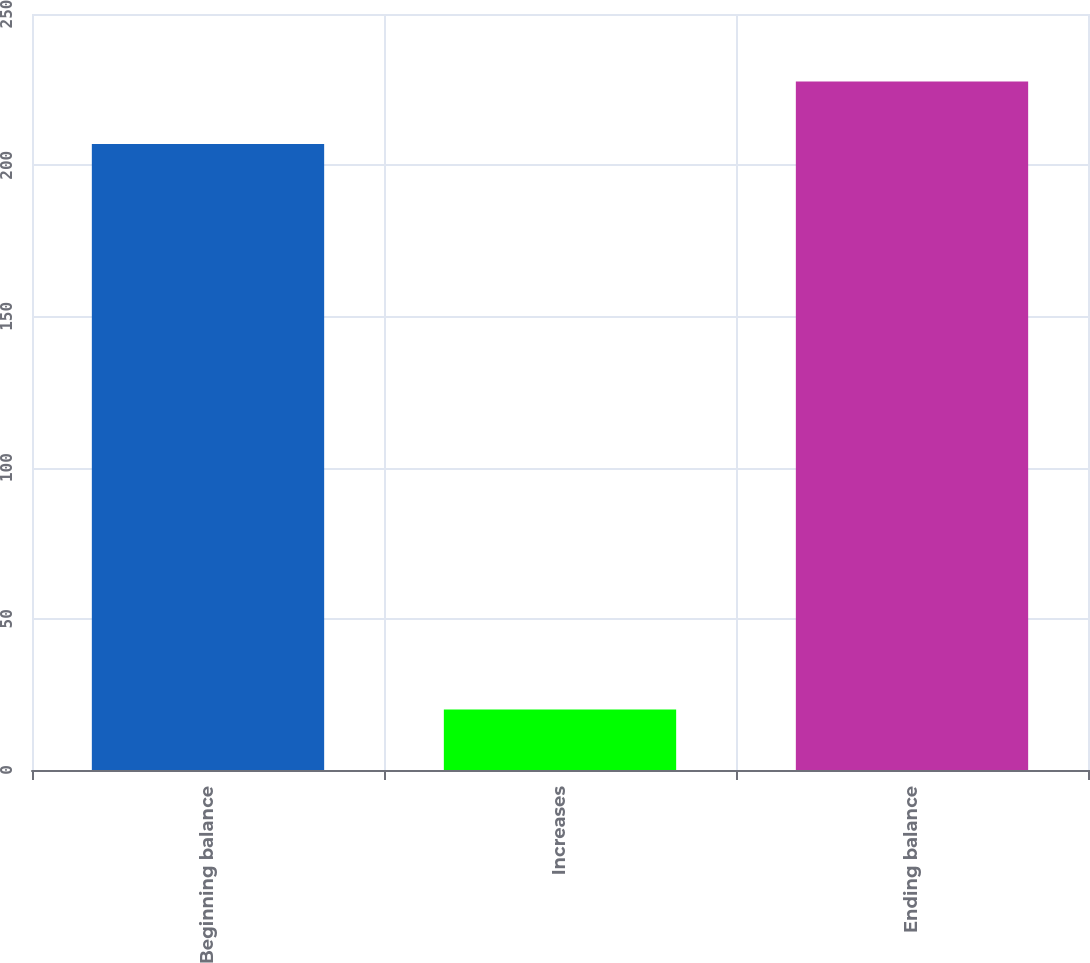Convert chart. <chart><loc_0><loc_0><loc_500><loc_500><bar_chart><fcel>Beginning balance<fcel>Increases<fcel>Ending balance<nl><fcel>207<fcel>20<fcel>227.7<nl></chart> 